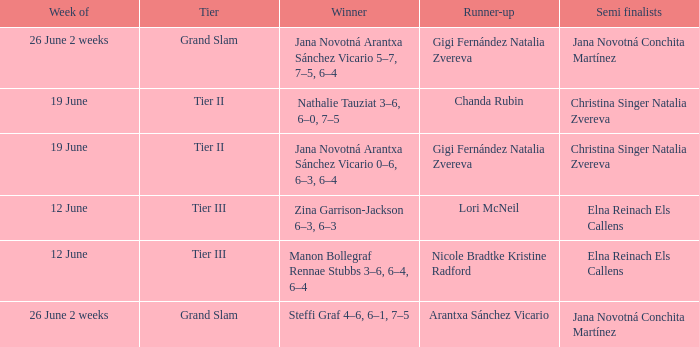In which week is the winner listed as Jana Novotná Arantxa Sánchez Vicario 5–7, 7–5, 6–4? 26 June 2 weeks. 